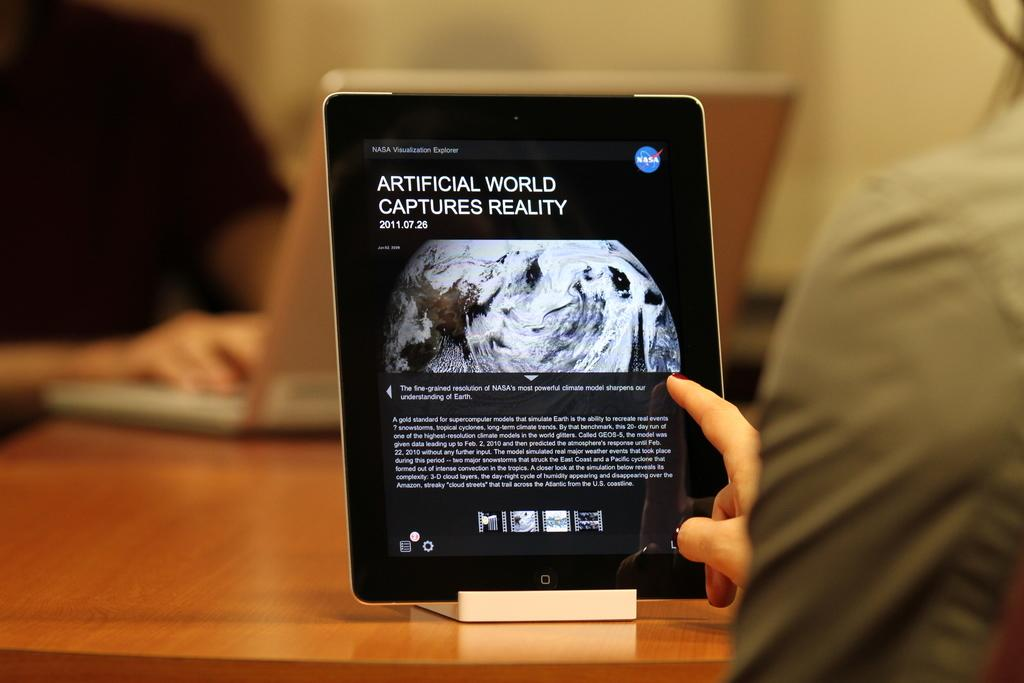What is the main feature of the image that contains text? There is a tab with text in the image. Can you describe the person in the image? There is a person on the right side of the image. What type of furniture is present at the bottom of the image? There is a table at the bottom of the image. Can you see the seashore in the background of the image? There is no seashore visible in the image. Is the person holding a key in the image? There is no key present in the image. 